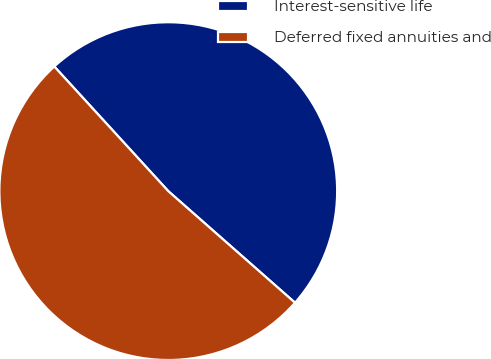Convert chart. <chart><loc_0><loc_0><loc_500><loc_500><pie_chart><fcel>Interest-sensitive life<fcel>Deferred fixed annuities and<nl><fcel>48.28%<fcel>51.72%<nl></chart> 